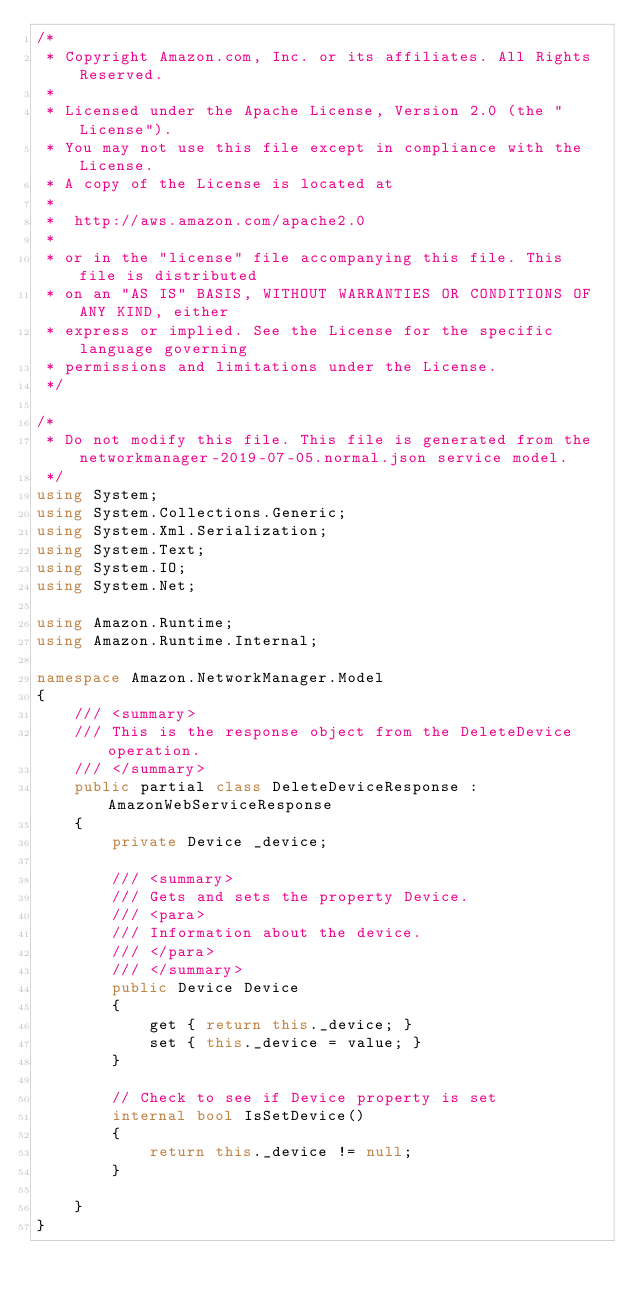Convert code to text. <code><loc_0><loc_0><loc_500><loc_500><_C#_>/*
 * Copyright Amazon.com, Inc. or its affiliates. All Rights Reserved.
 * 
 * Licensed under the Apache License, Version 2.0 (the "License").
 * You may not use this file except in compliance with the License.
 * A copy of the License is located at
 * 
 *  http://aws.amazon.com/apache2.0
 * 
 * or in the "license" file accompanying this file. This file is distributed
 * on an "AS IS" BASIS, WITHOUT WARRANTIES OR CONDITIONS OF ANY KIND, either
 * express or implied. See the License for the specific language governing
 * permissions and limitations under the License.
 */

/*
 * Do not modify this file. This file is generated from the networkmanager-2019-07-05.normal.json service model.
 */
using System;
using System.Collections.Generic;
using System.Xml.Serialization;
using System.Text;
using System.IO;
using System.Net;

using Amazon.Runtime;
using Amazon.Runtime.Internal;

namespace Amazon.NetworkManager.Model
{
    /// <summary>
    /// This is the response object from the DeleteDevice operation.
    /// </summary>
    public partial class DeleteDeviceResponse : AmazonWebServiceResponse
    {
        private Device _device;

        /// <summary>
        /// Gets and sets the property Device. 
        /// <para>
        /// Information about the device.
        /// </para>
        /// </summary>
        public Device Device
        {
            get { return this._device; }
            set { this._device = value; }
        }

        // Check to see if Device property is set
        internal bool IsSetDevice()
        {
            return this._device != null;
        }

    }
}</code> 